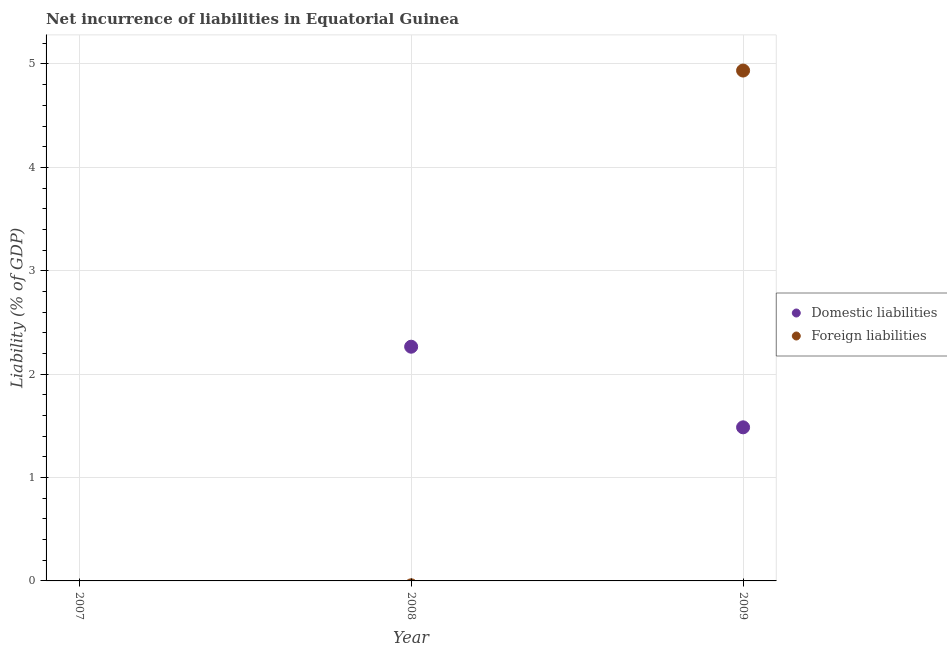How many different coloured dotlines are there?
Offer a terse response. 2. What is the incurrence of domestic liabilities in 2008?
Keep it short and to the point. 2.27. Across all years, what is the maximum incurrence of foreign liabilities?
Your response must be concise. 4.94. Across all years, what is the minimum incurrence of domestic liabilities?
Offer a very short reply. 0. In which year was the incurrence of foreign liabilities maximum?
Your answer should be compact. 2009. What is the total incurrence of foreign liabilities in the graph?
Your answer should be very brief. 4.94. What is the difference between the incurrence of domestic liabilities in 2008 and that in 2009?
Keep it short and to the point. 0.78. What is the average incurrence of foreign liabilities per year?
Your answer should be very brief. 1.65. In the year 2009, what is the difference between the incurrence of foreign liabilities and incurrence of domestic liabilities?
Keep it short and to the point. 3.45. In how many years, is the incurrence of domestic liabilities greater than 2.8 %?
Make the answer very short. 0. What is the ratio of the incurrence of domestic liabilities in 2008 to that in 2009?
Give a very brief answer. 1.52. What is the difference between the highest and the lowest incurrence of foreign liabilities?
Offer a very short reply. 4.94. Is the sum of the incurrence of domestic liabilities in 2008 and 2009 greater than the maximum incurrence of foreign liabilities across all years?
Provide a succinct answer. No. Does the incurrence of domestic liabilities monotonically increase over the years?
Your answer should be compact. No. Is the incurrence of domestic liabilities strictly greater than the incurrence of foreign liabilities over the years?
Your response must be concise. No. How many dotlines are there?
Keep it short and to the point. 2. What is the difference between two consecutive major ticks on the Y-axis?
Make the answer very short. 1. Are the values on the major ticks of Y-axis written in scientific E-notation?
Offer a very short reply. No. Does the graph contain any zero values?
Your response must be concise. Yes. Does the graph contain grids?
Offer a very short reply. Yes. Where does the legend appear in the graph?
Keep it short and to the point. Center right. What is the title of the graph?
Your answer should be very brief. Net incurrence of liabilities in Equatorial Guinea. What is the label or title of the X-axis?
Your answer should be very brief. Year. What is the label or title of the Y-axis?
Offer a terse response. Liability (% of GDP). What is the Liability (% of GDP) of Foreign liabilities in 2007?
Keep it short and to the point. 0. What is the Liability (% of GDP) in Domestic liabilities in 2008?
Your answer should be compact. 2.27. What is the Liability (% of GDP) in Foreign liabilities in 2008?
Your answer should be very brief. 0. What is the Liability (% of GDP) of Domestic liabilities in 2009?
Your answer should be very brief. 1.49. What is the Liability (% of GDP) of Foreign liabilities in 2009?
Provide a short and direct response. 4.94. Across all years, what is the maximum Liability (% of GDP) of Domestic liabilities?
Make the answer very short. 2.27. Across all years, what is the maximum Liability (% of GDP) in Foreign liabilities?
Ensure brevity in your answer.  4.94. Across all years, what is the minimum Liability (% of GDP) of Domestic liabilities?
Provide a succinct answer. 0. Across all years, what is the minimum Liability (% of GDP) in Foreign liabilities?
Offer a terse response. 0. What is the total Liability (% of GDP) in Domestic liabilities in the graph?
Provide a succinct answer. 3.75. What is the total Liability (% of GDP) of Foreign liabilities in the graph?
Give a very brief answer. 4.94. What is the difference between the Liability (% of GDP) in Domestic liabilities in 2008 and that in 2009?
Keep it short and to the point. 0.78. What is the difference between the Liability (% of GDP) in Domestic liabilities in 2008 and the Liability (% of GDP) in Foreign liabilities in 2009?
Make the answer very short. -2.67. What is the average Liability (% of GDP) of Domestic liabilities per year?
Offer a very short reply. 1.25. What is the average Liability (% of GDP) in Foreign liabilities per year?
Give a very brief answer. 1.65. In the year 2009, what is the difference between the Liability (% of GDP) of Domestic liabilities and Liability (% of GDP) of Foreign liabilities?
Your answer should be very brief. -3.45. What is the ratio of the Liability (% of GDP) in Domestic liabilities in 2008 to that in 2009?
Provide a succinct answer. 1.52. What is the difference between the highest and the lowest Liability (% of GDP) of Domestic liabilities?
Your answer should be compact. 2.27. What is the difference between the highest and the lowest Liability (% of GDP) in Foreign liabilities?
Give a very brief answer. 4.94. 